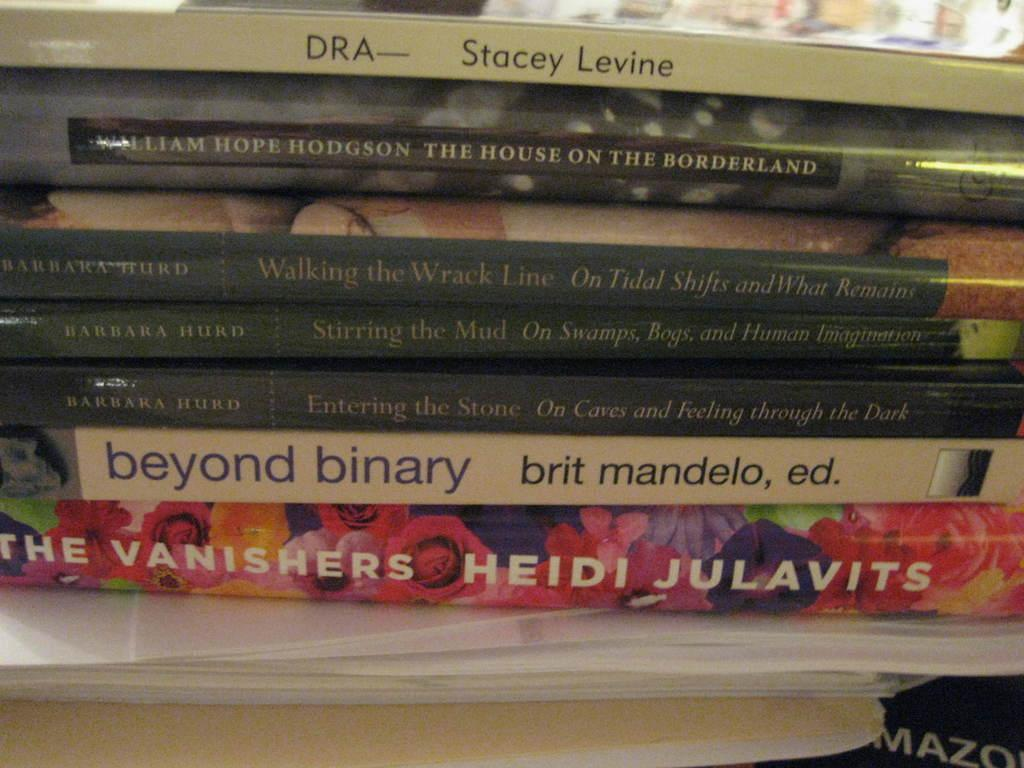<image>
Summarize the visual content of the image. A book called "Beyond Binary" is underneath "Entering the Stone" in a stack. 